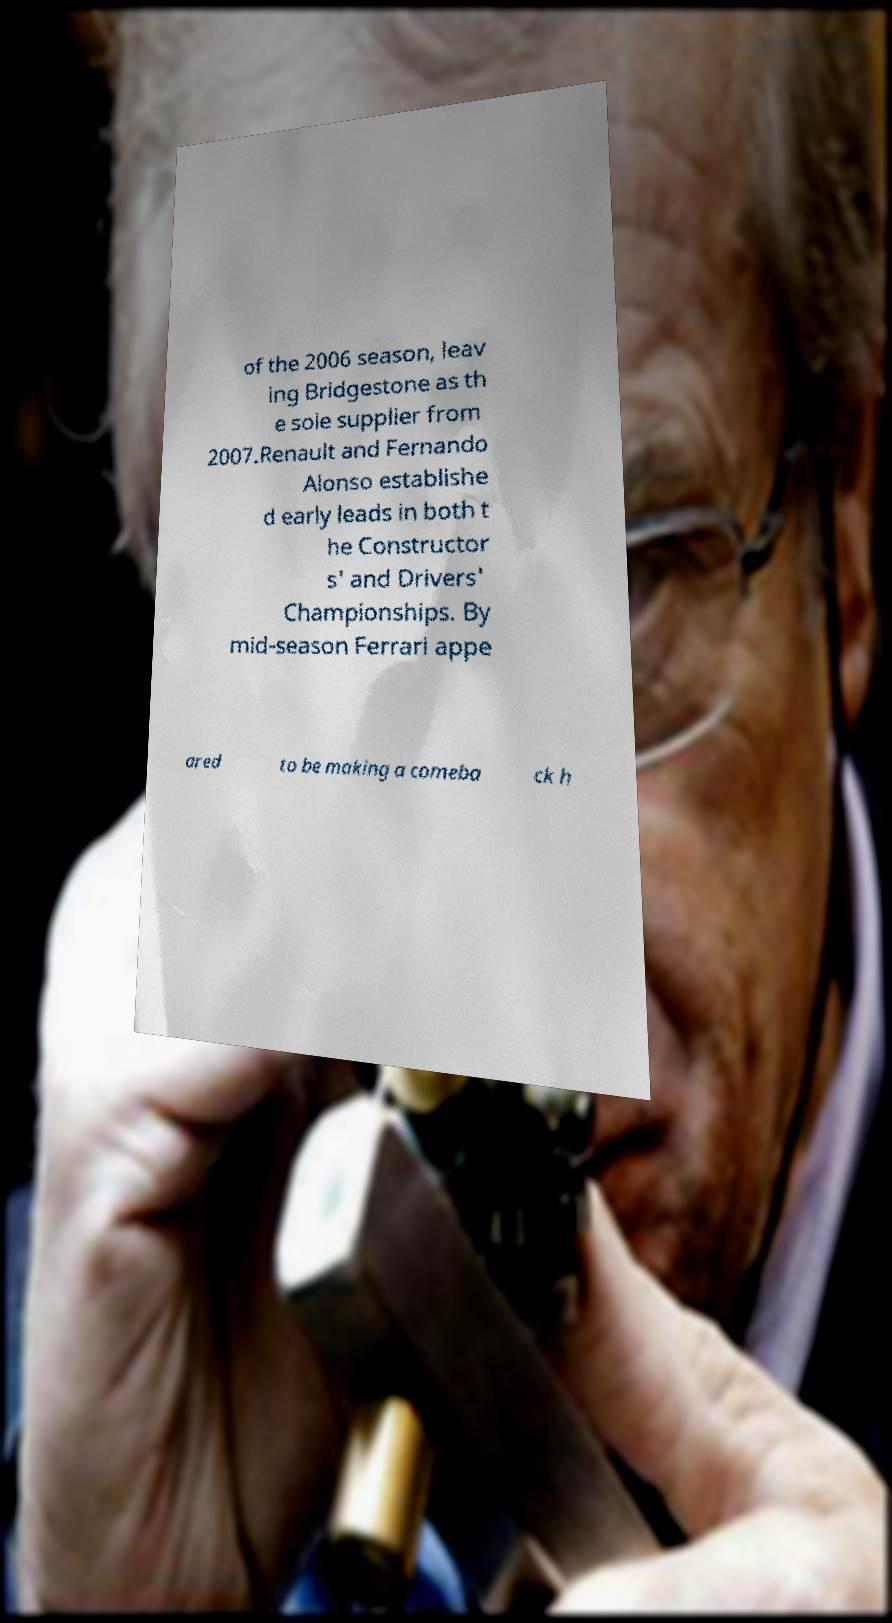Please read and relay the text visible in this image. What does it say? of the 2006 season, leav ing Bridgestone as th e sole supplier from 2007.Renault and Fernando Alonso establishe d early leads in both t he Constructor s' and Drivers' Championships. By mid-season Ferrari appe ared to be making a comeba ck h 